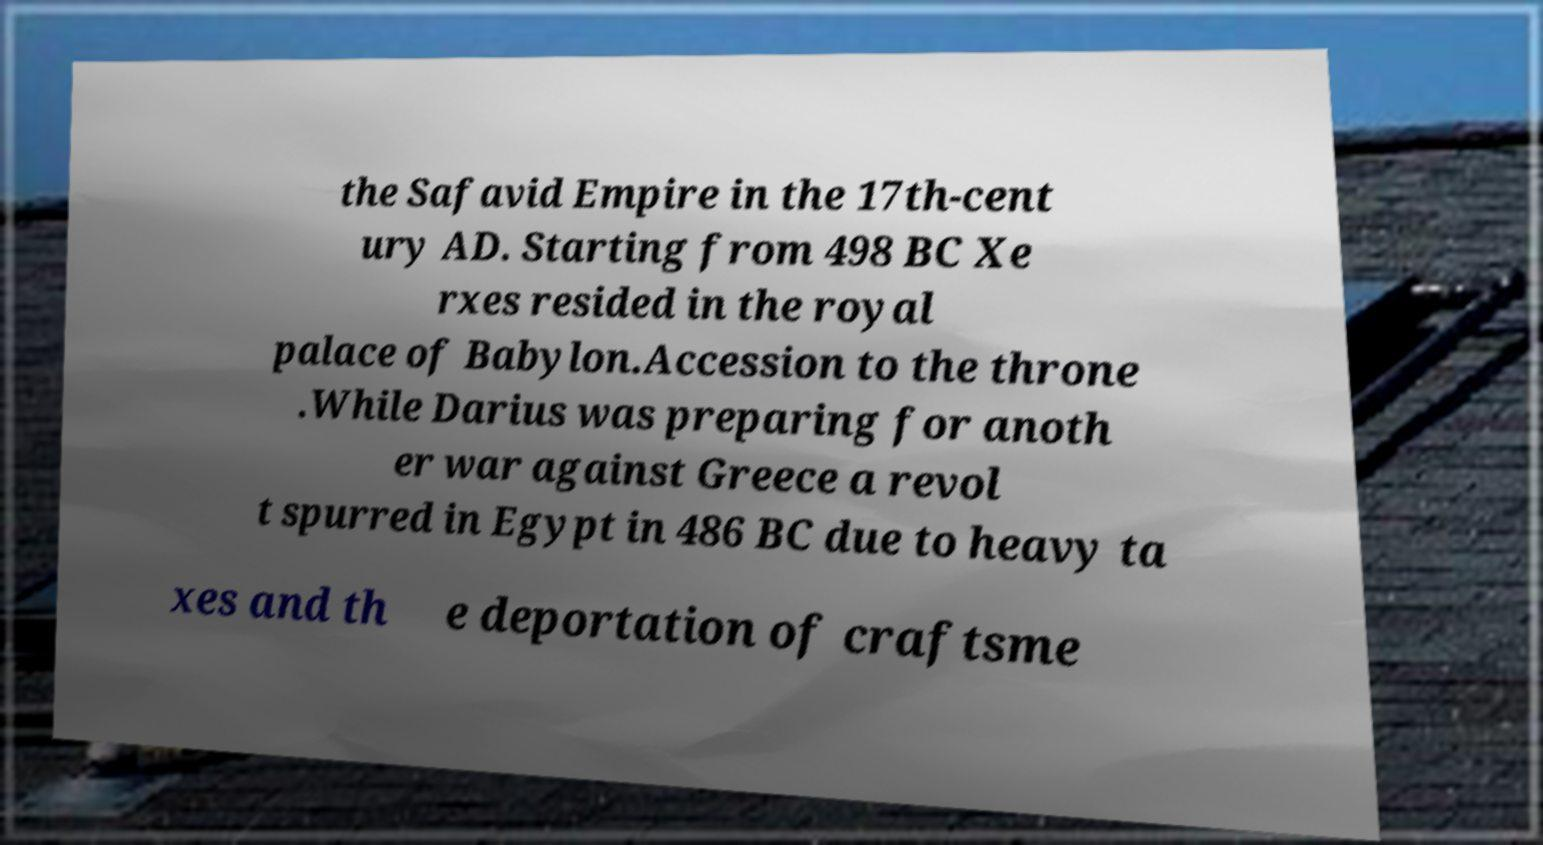Can you accurately transcribe the text from the provided image for me? the Safavid Empire in the 17th-cent ury AD. Starting from 498 BC Xe rxes resided in the royal palace of Babylon.Accession to the throne .While Darius was preparing for anoth er war against Greece a revol t spurred in Egypt in 486 BC due to heavy ta xes and th e deportation of craftsme 